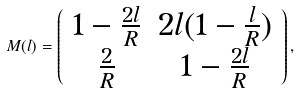Convert formula to latex. <formula><loc_0><loc_0><loc_500><loc_500>M ( l ) = \left ( \begin{array} { c c } 1 - \frac { 2 l } { R } & 2 l ( 1 - \frac { l } { R } ) \\ \frac { 2 } { R } & 1 - \frac { 2 l } { R } \end{array} \right ) ,</formula> 